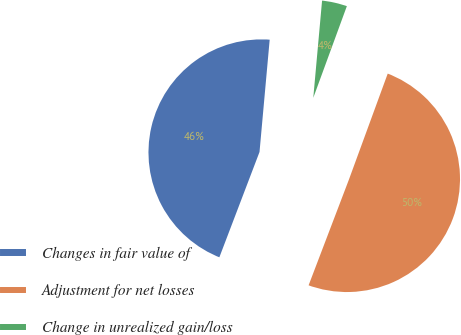Convert chart. <chart><loc_0><loc_0><loc_500><loc_500><pie_chart><fcel>Changes in fair value of<fcel>Adjustment for net losses<fcel>Change in unrealized gain/loss<nl><fcel>45.64%<fcel>50.21%<fcel>4.15%<nl></chart> 